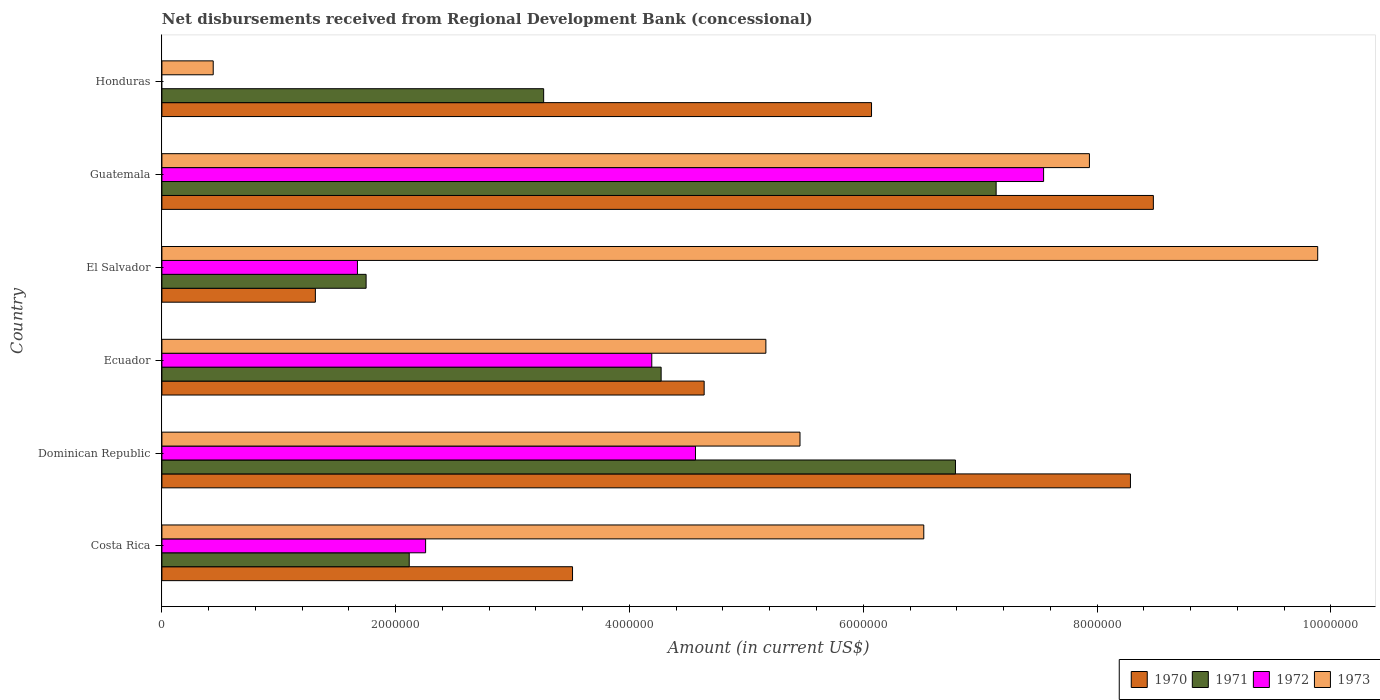How many different coloured bars are there?
Offer a terse response. 4. How many groups of bars are there?
Give a very brief answer. 6. What is the label of the 6th group of bars from the top?
Provide a short and direct response. Costa Rica. What is the amount of disbursements received from Regional Development Bank in 1972 in Honduras?
Make the answer very short. 0. Across all countries, what is the maximum amount of disbursements received from Regional Development Bank in 1970?
Make the answer very short. 8.48e+06. Across all countries, what is the minimum amount of disbursements received from Regional Development Bank in 1971?
Your response must be concise. 1.75e+06. In which country was the amount of disbursements received from Regional Development Bank in 1971 maximum?
Provide a short and direct response. Guatemala. What is the total amount of disbursements received from Regional Development Bank in 1973 in the graph?
Your answer should be compact. 3.54e+07. What is the difference between the amount of disbursements received from Regional Development Bank in 1973 in Dominican Republic and that in Ecuador?
Provide a short and direct response. 2.92e+05. What is the difference between the amount of disbursements received from Regional Development Bank in 1971 in Dominican Republic and the amount of disbursements received from Regional Development Bank in 1973 in Ecuador?
Provide a short and direct response. 1.62e+06. What is the average amount of disbursements received from Regional Development Bank in 1970 per country?
Offer a terse response. 5.38e+06. What is the difference between the amount of disbursements received from Regional Development Bank in 1972 and amount of disbursements received from Regional Development Bank in 1970 in Costa Rica?
Ensure brevity in your answer.  -1.26e+06. In how many countries, is the amount of disbursements received from Regional Development Bank in 1970 greater than 6000000 US$?
Offer a terse response. 3. What is the ratio of the amount of disbursements received from Regional Development Bank in 1971 in El Salvador to that in Guatemala?
Make the answer very short. 0.24. What is the difference between the highest and the second highest amount of disbursements received from Regional Development Bank in 1972?
Provide a short and direct response. 2.98e+06. What is the difference between the highest and the lowest amount of disbursements received from Regional Development Bank in 1973?
Your answer should be very brief. 9.45e+06. In how many countries, is the amount of disbursements received from Regional Development Bank in 1973 greater than the average amount of disbursements received from Regional Development Bank in 1973 taken over all countries?
Your response must be concise. 3. Are all the bars in the graph horizontal?
Your response must be concise. Yes. What is the difference between two consecutive major ticks on the X-axis?
Offer a terse response. 2.00e+06. Does the graph contain any zero values?
Your response must be concise. Yes. Does the graph contain grids?
Give a very brief answer. No. How are the legend labels stacked?
Provide a short and direct response. Horizontal. What is the title of the graph?
Your answer should be compact. Net disbursements received from Regional Development Bank (concessional). Does "1976" appear as one of the legend labels in the graph?
Your response must be concise. No. What is the Amount (in current US$) in 1970 in Costa Rica?
Provide a short and direct response. 3.51e+06. What is the Amount (in current US$) in 1971 in Costa Rica?
Your answer should be very brief. 2.12e+06. What is the Amount (in current US$) of 1972 in Costa Rica?
Your answer should be compact. 2.26e+06. What is the Amount (in current US$) in 1973 in Costa Rica?
Provide a succinct answer. 6.52e+06. What is the Amount (in current US$) of 1970 in Dominican Republic?
Provide a short and direct response. 8.29e+06. What is the Amount (in current US$) of 1971 in Dominican Republic?
Give a very brief answer. 6.79e+06. What is the Amount (in current US$) of 1972 in Dominican Republic?
Your answer should be compact. 4.56e+06. What is the Amount (in current US$) in 1973 in Dominican Republic?
Provide a short and direct response. 5.46e+06. What is the Amount (in current US$) of 1970 in Ecuador?
Your response must be concise. 4.64e+06. What is the Amount (in current US$) in 1971 in Ecuador?
Your answer should be very brief. 4.27e+06. What is the Amount (in current US$) of 1972 in Ecuador?
Your answer should be very brief. 4.19e+06. What is the Amount (in current US$) of 1973 in Ecuador?
Keep it short and to the point. 5.17e+06. What is the Amount (in current US$) in 1970 in El Salvador?
Provide a succinct answer. 1.31e+06. What is the Amount (in current US$) of 1971 in El Salvador?
Make the answer very short. 1.75e+06. What is the Amount (in current US$) in 1972 in El Salvador?
Provide a short and direct response. 1.67e+06. What is the Amount (in current US$) in 1973 in El Salvador?
Your response must be concise. 9.89e+06. What is the Amount (in current US$) of 1970 in Guatemala?
Give a very brief answer. 8.48e+06. What is the Amount (in current US$) of 1971 in Guatemala?
Your response must be concise. 7.14e+06. What is the Amount (in current US$) in 1972 in Guatemala?
Keep it short and to the point. 7.54e+06. What is the Amount (in current US$) of 1973 in Guatemala?
Your response must be concise. 7.94e+06. What is the Amount (in current US$) of 1970 in Honduras?
Give a very brief answer. 6.07e+06. What is the Amount (in current US$) in 1971 in Honduras?
Make the answer very short. 3.27e+06. What is the Amount (in current US$) of 1972 in Honduras?
Give a very brief answer. 0. What is the Amount (in current US$) in 1973 in Honduras?
Your response must be concise. 4.39e+05. Across all countries, what is the maximum Amount (in current US$) of 1970?
Your answer should be very brief. 8.48e+06. Across all countries, what is the maximum Amount (in current US$) in 1971?
Keep it short and to the point. 7.14e+06. Across all countries, what is the maximum Amount (in current US$) of 1972?
Ensure brevity in your answer.  7.54e+06. Across all countries, what is the maximum Amount (in current US$) in 1973?
Make the answer very short. 9.89e+06. Across all countries, what is the minimum Amount (in current US$) of 1970?
Make the answer very short. 1.31e+06. Across all countries, what is the minimum Amount (in current US$) in 1971?
Provide a succinct answer. 1.75e+06. Across all countries, what is the minimum Amount (in current US$) of 1972?
Offer a very short reply. 0. Across all countries, what is the minimum Amount (in current US$) of 1973?
Ensure brevity in your answer.  4.39e+05. What is the total Amount (in current US$) of 1970 in the graph?
Provide a succinct answer. 3.23e+07. What is the total Amount (in current US$) in 1971 in the graph?
Your response must be concise. 2.53e+07. What is the total Amount (in current US$) in 1972 in the graph?
Your answer should be compact. 2.02e+07. What is the total Amount (in current US$) of 1973 in the graph?
Provide a short and direct response. 3.54e+07. What is the difference between the Amount (in current US$) in 1970 in Costa Rica and that in Dominican Republic?
Offer a very short reply. -4.77e+06. What is the difference between the Amount (in current US$) in 1971 in Costa Rica and that in Dominican Republic?
Make the answer very short. -4.67e+06. What is the difference between the Amount (in current US$) of 1972 in Costa Rica and that in Dominican Republic?
Offer a terse response. -2.31e+06. What is the difference between the Amount (in current US$) of 1973 in Costa Rica and that in Dominican Republic?
Offer a very short reply. 1.06e+06. What is the difference between the Amount (in current US$) in 1970 in Costa Rica and that in Ecuador?
Give a very brief answer. -1.13e+06. What is the difference between the Amount (in current US$) in 1971 in Costa Rica and that in Ecuador?
Offer a terse response. -2.16e+06. What is the difference between the Amount (in current US$) in 1972 in Costa Rica and that in Ecuador?
Your response must be concise. -1.94e+06. What is the difference between the Amount (in current US$) in 1973 in Costa Rica and that in Ecuador?
Provide a short and direct response. 1.35e+06. What is the difference between the Amount (in current US$) in 1970 in Costa Rica and that in El Salvador?
Make the answer very short. 2.20e+06. What is the difference between the Amount (in current US$) of 1971 in Costa Rica and that in El Salvador?
Make the answer very short. 3.69e+05. What is the difference between the Amount (in current US$) of 1972 in Costa Rica and that in El Salvador?
Provide a short and direct response. 5.83e+05. What is the difference between the Amount (in current US$) of 1973 in Costa Rica and that in El Salvador?
Your answer should be very brief. -3.37e+06. What is the difference between the Amount (in current US$) in 1970 in Costa Rica and that in Guatemala?
Give a very brief answer. -4.97e+06. What is the difference between the Amount (in current US$) of 1971 in Costa Rica and that in Guatemala?
Make the answer very short. -5.02e+06. What is the difference between the Amount (in current US$) of 1972 in Costa Rica and that in Guatemala?
Your answer should be very brief. -5.29e+06. What is the difference between the Amount (in current US$) in 1973 in Costa Rica and that in Guatemala?
Your answer should be compact. -1.42e+06. What is the difference between the Amount (in current US$) in 1970 in Costa Rica and that in Honduras?
Make the answer very short. -2.56e+06. What is the difference between the Amount (in current US$) of 1971 in Costa Rica and that in Honduras?
Offer a terse response. -1.15e+06. What is the difference between the Amount (in current US$) of 1973 in Costa Rica and that in Honduras?
Provide a short and direct response. 6.08e+06. What is the difference between the Amount (in current US$) of 1970 in Dominican Republic and that in Ecuador?
Provide a succinct answer. 3.65e+06. What is the difference between the Amount (in current US$) in 1971 in Dominican Republic and that in Ecuador?
Give a very brief answer. 2.52e+06. What is the difference between the Amount (in current US$) in 1972 in Dominican Republic and that in Ecuador?
Give a very brief answer. 3.74e+05. What is the difference between the Amount (in current US$) of 1973 in Dominican Republic and that in Ecuador?
Your response must be concise. 2.92e+05. What is the difference between the Amount (in current US$) in 1970 in Dominican Republic and that in El Salvador?
Provide a short and direct response. 6.97e+06. What is the difference between the Amount (in current US$) in 1971 in Dominican Republic and that in El Salvador?
Make the answer very short. 5.04e+06. What is the difference between the Amount (in current US$) of 1972 in Dominican Republic and that in El Salvador?
Your answer should be compact. 2.89e+06. What is the difference between the Amount (in current US$) in 1973 in Dominican Republic and that in El Salvador?
Keep it short and to the point. -4.43e+06. What is the difference between the Amount (in current US$) of 1970 in Dominican Republic and that in Guatemala?
Provide a succinct answer. -1.96e+05. What is the difference between the Amount (in current US$) in 1971 in Dominican Republic and that in Guatemala?
Provide a succinct answer. -3.48e+05. What is the difference between the Amount (in current US$) in 1972 in Dominican Republic and that in Guatemala?
Offer a terse response. -2.98e+06. What is the difference between the Amount (in current US$) of 1973 in Dominican Republic and that in Guatemala?
Provide a succinct answer. -2.48e+06. What is the difference between the Amount (in current US$) of 1970 in Dominican Republic and that in Honduras?
Offer a terse response. 2.22e+06. What is the difference between the Amount (in current US$) of 1971 in Dominican Republic and that in Honduras?
Give a very brief answer. 3.52e+06. What is the difference between the Amount (in current US$) in 1973 in Dominican Republic and that in Honduras?
Your response must be concise. 5.02e+06. What is the difference between the Amount (in current US$) of 1970 in Ecuador and that in El Salvador?
Keep it short and to the point. 3.33e+06. What is the difference between the Amount (in current US$) of 1971 in Ecuador and that in El Salvador?
Your answer should be compact. 2.52e+06. What is the difference between the Amount (in current US$) in 1972 in Ecuador and that in El Salvador?
Offer a very short reply. 2.52e+06. What is the difference between the Amount (in current US$) in 1973 in Ecuador and that in El Salvador?
Ensure brevity in your answer.  -4.72e+06. What is the difference between the Amount (in current US$) of 1970 in Ecuador and that in Guatemala?
Provide a short and direct response. -3.84e+06. What is the difference between the Amount (in current US$) in 1971 in Ecuador and that in Guatemala?
Provide a succinct answer. -2.87e+06. What is the difference between the Amount (in current US$) in 1972 in Ecuador and that in Guatemala?
Make the answer very short. -3.35e+06. What is the difference between the Amount (in current US$) of 1973 in Ecuador and that in Guatemala?
Provide a short and direct response. -2.77e+06. What is the difference between the Amount (in current US$) in 1970 in Ecuador and that in Honduras?
Provide a short and direct response. -1.43e+06. What is the difference between the Amount (in current US$) in 1971 in Ecuador and that in Honduras?
Your answer should be very brief. 1.00e+06. What is the difference between the Amount (in current US$) in 1973 in Ecuador and that in Honduras?
Offer a very short reply. 4.73e+06. What is the difference between the Amount (in current US$) of 1970 in El Salvador and that in Guatemala?
Give a very brief answer. -7.17e+06. What is the difference between the Amount (in current US$) of 1971 in El Salvador and that in Guatemala?
Make the answer very short. -5.39e+06. What is the difference between the Amount (in current US$) of 1972 in El Salvador and that in Guatemala?
Your answer should be compact. -5.87e+06. What is the difference between the Amount (in current US$) in 1973 in El Salvador and that in Guatemala?
Offer a very short reply. 1.95e+06. What is the difference between the Amount (in current US$) in 1970 in El Salvador and that in Honduras?
Provide a succinct answer. -4.76e+06. What is the difference between the Amount (in current US$) of 1971 in El Salvador and that in Honduras?
Keep it short and to the point. -1.52e+06. What is the difference between the Amount (in current US$) of 1973 in El Salvador and that in Honduras?
Make the answer very short. 9.45e+06. What is the difference between the Amount (in current US$) of 1970 in Guatemala and that in Honduras?
Your response must be concise. 2.41e+06. What is the difference between the Amount (in current US$) of 1971 in Guatemala and that in Honduras?
Make the answer very short. 3.87e+06. What is the difference between the Amount (in current US$) of 1973 in Guatemala and that in Honduras?
Offer a terse response. 7.50e+06. What is the difference between the Amount (in current US$) in 1970 in Costa Rica and the Amount (in current US$) in 1971 in Dominican Republic?
Ensure brevity in your answer.  -3.28e+06. What is the difference between the Amount (in current US$) in 1970 in Costa Rica and the Amount (in current US$) in 1972 in Dominican Republic?
Make the answer very short. -1.05e+06. What is the difference between the Amount (in current US$) of 1970 in Costa Rica and the Amount (in current US$) of 1973 in Dominican Republic?
Your response must be concise. -1.95e+06. What is the difference between the Amount (in current US$) in 1971 in Costa Rica and the Amount (in current US$) in 1972 in Dominican Republic?
Provide a succinct answer. -2.45e+06. What is the difference between the Amount (in current US$) of 1971 in Costa Rica and the Amount (in current US$) of 1973 in Dominican Republic?
Make the answer very short. -3.34e+06. What is the difference between the Amount (in current US$) in 1972 in Costa Rica and the Amount (in current US$) in 1973 in Dominican Republic?
Keep it short and to the point. -3.20e+06. What is the difference between the Amount (in current US$) of 1970 in Costa Rica and the Amount (in current US$) of 1971 in Ecuador?
Your response must be concise. -7.58e+05. What is the difference between the Amount (in current US$) in 1970 in Costa Rica and the Amount (in current US$) in 1972 in Ecuador?
Your answer should be compact. -6.78e+05. What is the difference between the Amount (in current US$) in 1970 in Costa Rica and the Amount (in current US$) in 1973 in Ecuador?
Offer a terse response. -1.65e+06. What is the difference between the Amount (in current US$) of 1971 in Costa Rica and the Amount (in current US$) of 1972 in Ecuador?
Ensure brevity in your answer.  -2.08e+06. What is the difference between the Amount (in current US$) in 1971 in Costa Rica and the Amount (in current US$) in 1973 in Ecuador?
Your response must be concise. -3.05e+06. What is the difference between the Amount (in current US$) of 1972 in Costa Rica and the Amount (in current US$) of 1973 in Ecuador?
Give a very brief answer. -2.91e+06. What is the difference between the Amount (in current US$) of 1970 in Costa Rica and the Amount (in current US$) of 1971 in El Salvador?
Make the answer very short. 1.77e+06. What is the difference between the Amount (in current US$) in 1970 in Costa Rica and the Amount (in current US$) in 1972 in El Salvador?
Your answer should be very brief. 1.84e+06. What is the difference between the Amount (in current US$) of 1970 in Costa Rica and the Amount (in current US$) of 1973 in El Salvador?
Offer a terse response. -6.38e+06. What is the difference between the Amount (in current US$) of 1971 in Costa Rica and the Amount (in current US$) of 1972 in El Salvador?
Your answer should be very brief. 4.43e+05. What is the difference between the Amount (in current US$) in 1971 in Costa Rica and the Amount (in current US$) in 1973 in El Salvador?
Give a very brief answer. -7.77e+06. What is the difference between the Amount (in current US$) of 1972 in Costa Rica and the Amount (in current US$) of 1973 in El Salvador?
Provide a succinct answer. -7.63e+06. What is the difference between the Amount (in current US$) in 1970 in Costa Rica and the Amount (in current US$) in 1971 in Guatemala?
Give a very brief answer. -3.62e+06. What is the difference between the Amount (in current US$) in 1970 in Costa Rica and the Amount (in current US$) in 1972 in Guatemala?
Provide a succinct answer. -4.03e+06. What is the difference between the Amount (in current US$) in 1970 in Costa Rica and the Amount (in current US$) in 1973 in Guatemala?
Keep it short and to the point. -4.42e+06. What is the difference between the Amount (in current US$) in 1971 in Costa Rica and the Amount (in current US$) in 1972 in Guatemala?
Your response must be concise. -5.43e+06. What is the difference between the Amount (in current US$) in 1971 in Costa Rica and the Amount (in current US$) in 1973 in Guatemala?
Give a very brief answer. -5.82e+06. What is the difference between the Amount (in current US$) in 1972 in Costa Rica and the Amount (in current US$) in 1973 in Guatemala?
Offer a very short reply. -5.68e+06. What is the difference between the Amount (in current US$) in 1970 in Costa Rica and the Amount (in current US$) in 1971 in Honduras?
Provide a succinct answer. 2.47e+05. What is the difference between the Amount (in current US$) of 1970 in Costa Rica and the Amount (in current US$) of 1973 in Honduras?
Provide a short and direct response. 3.07e+06. What is the difference between the Amount (in current US$) in 1971 in Costa Rica and the Amount (in current US$) in 1973 in Honduras?
Your answer should be compact. 1.68e+06. What is the difference between the Amount (in current US$) in 1972 in Costa Rica and the Amount (in current US$) in 1973 in Honduras?
Make the answer very short. 1.82e+06. What is the difference between the Amount (in current US$) in 1970 in Dominican Republic and the Amount (in current US$) in 1971 in Ecuador?
Offer a very short reply. 4.02e+06. What is the difference between the Amount (in current US$) in 1970 in Dominican Republic and the Amount (in current US$) in 1972 in Ecuador?
Ensure brevity in your answer.  4.10e+06. What is the difference between the Amount (in current US$) in 1970 in Dominican Republic and the Amount (in current US$) in 1973 in Ecuador?
Your answer should be compact. 3.12e+06. What is the difference between the Amount (in current US$) in 1971 in Dominican Republic and the Amount (in current US$) in 1972 in Ecuador?
Keep it short and to the point. 2.60e+06. What is the difference between the Amount (in current US$) of 1971 in Dominican Republic and the Amount (in current US$) of 1973 in Ecuador?
Your response must be concise. 1.62e+06. What is the difference between the Amount (in current US$) in 1972 in Dominican Republic and the Amount (in current US$) in 1973 in Ecuador?
Provide a short and direct response. -6.02e+05. What is the difference between the Amount (in current US$) of 1970 in Dominican Republic and the Amount (in current US$) of 1971 in El Salvador?
Make the answer very short. 6.54e+06. What is the difference between the Amount (in current US$) of 1970 in Dominican Republic and the Amount (in current US$) of 1972 in El Salvador?
Provide a short and direct response. 6.61e+06. What is the difference between the Amount (in current US$) of 1970 in Dominican Republic and the Amount (in current US$) of 1973 in El Salvador?
Your response must be concise. -1.60e+06. What is the difference between the Amount (in current US$) of 1971 in Dominican Republic and the Amount (in current US$) of 1972 in El Salvador?
Provide a short and direct response. 5.12e+06. What is the difference between the Amount (in current US$) of 1971 in Dominican Republic and the Amount (in current US$) of 1973 in El Salvador?
Give a very brief answer. -3.10e+06. What is the difference between the Amount (in current US$) of 1972 in Dominican Republic and the Amount (in current US$) of 1973 in El Salvador?
Provide a succinct answer. -5.32e+06. What is the difference between the Amount (in current US$) in 1970 in Dominican Republic and the Amount (in current US$) in 1971 in Guatemala?
Offer a terse response. 1.15e+06. What is the difference between the Amount (in current US$) in 1970 in Dominican Republic and the Amount (in current US$) in 1972 in Guatemala?
Keep it short and to the point. 7.43e+05. What is the difference between the Amount (in current US$) in 1970 in Dominican Republic and the Amount (in current US$) in 1973 in Guatemala?
Keep it short and to the point. 3.51e+05. What is the difference between the Amount (in current US$) of 1971 in Dominican Republic and the Amount (in current US$) of 1972 in Guatemala?
Provide a short and direct response. -7.54e+05. What is the difference between the Amount (in current US$) of 1971 in Dominican Republic and the Amount (in current US$) of 1973 in Guatemala?
Give a very brief answer. -1.15e+06. What is the difference between the Amount (in current US$) of 1972 in Dominican Republic and the Amount (in current US$) of 1973 in Guatemala?
Offer a very short reply. -3.37e+06. What is the difference between the Amount (in current US$) in 1970 in Dominican Republic and the Amount (in current US$) in 1971 in Honduras?
Your answer should be very brief. 5.02e+06. What is the difference between the Amount (in current US$) in 1970 in Dominican Republic and the Amount (in current US$) in 1973 in Honduras?
Give a very brief answer. 7.85e+06. What is the difference between the Amount (in current US$) in 1971 in Dominican Republic and the Amount (in current US$) in 1973 in Honduras?
Offer a terse response. 6.35e+06. What is the difference between the Amount (in current US$) in 1972 in Dominican Republic and the Amount (in current US$) in 1973 in Honduras?
Give a very brief answer. 4.13e+06. What is the difference between the Amount (in current US$) in 1970 in Ecuador and the Amount (in current US$) in 1971 in El Salvador?
Your answer should be compact. 2.89e+06. What is the difference between the Amount (in current US$) of 1970 in Ecuador and the Amount (in current US$) of 1972 in El Salvador?
Make the answer very short. 2.97e+06. What is the difference between the Amount (in current US$) of 1970 in Ecuador and the Amount (in current US$) of 1973 in El Salvador?
Offer a terse response. -5.25e+06. What is the difference between the Amount (in current US$) in 1971 in Ecuador and the Amount (in current US$) in 1972 in El Salvador?
Offer a terse response. 2.60e+06. What is the difference between the Amount (in current US$) in 1971 in Ecuador and the Amount (in current US$) in 1973 in El Salvador?
Provide a short and direct response. -5.62e+06. What is the difference between the Amount (in current US$) in 1972 in Ecuador and the Amount (in current US$) in 1973 in El Salvador?
Make the answer very short. -5.70e+06. What is the difference between the Amount (in current US$) of 1970 in Ecuador and the Amount (in current US$) of 1971 in Guatemala?
Provide a short and direct response. -2.50e+06. What is the difference between the Amount (in current US$) of 1970 in Ecuador and the Amount (in current US$) of 1972 in Guatemala?
Your response must be concise. -2.90e+06. What is the difference between the Amount (in current US$) of 1970 in Ecuador and the Amount (in current US$) of 1973 in Guatemala?
Offer a terse response. -3.30e+06. What is the difference between the Amount (in current US$) of 1971 in Ecuador and the Amount (in current US$) of 1972 in Guatemala?
Ensure brevity in your answer.  -3.27e+06. What is the difference between the Amount (in current US$) in 1971 in Ecuador and the Amount (in current US$) in 1973 in Guatemala?
Offer a terse response. -3.66e+06. What is the difference between the Amount (in current US$) of 1972 in Ecuador and the Amount (in current US$) of 1973 in Guatemala?
Provide a short and direct response. -3.74e+06. What is the difference between the Amount (in current US$) in 1970 in Ecuador and the Amount (in current US$) in 1971 in Honduras?
Your answer should be compact. 1.37e+06. What is the difference between the Amount (in current US$) in 1970 in Ecuador and the Amount (in current US$) in 1973 in Honduras?
Ensure brevity in your answer.  4.20e+06. What is the difference between the Amount (in current US$) in 1971 in Ecuador and the Amount (in current US$) in 1973 in Honduras?
Offer a very short reply. 3.83e+06. What is the difference between the Amount (in current US$) in 1972 in Ecuador and the Amount (in current US$) in 1973 in Honduras?
Make the answer very short. 3.75e+06. What is the difference between the Amount (in current US$) in 1970 in El Salvador and the Amount (in current US$) in 1971 in Guatemala?
Offer a terse response. -5.82e+06. What is the difference between the Amount (in current US$) in 1970 in El Salvador and the Amount (in current US$) in 1972 in Guatemala?
Keep it short and to the point. -6.23e+06. What is the difference between the Amount (in current US$) of 1970 in El Salvador and the Amount (in current US$) of 1973 in Guatemala?
Keep it short and to the point. -6.62e+06. What is the difference between the Amount (in current US$) in 1971 in El Salvador and the Amount (in current US$) in 1972 in Guatemala?
Provide a short and direct response. -5.80e+06. What is the difference between the Amount (in current US$) of 1971 in El Salvador and the Amount (in current US$) of 1973 in Guatemala?
Ensure brevity in your answer.  -6.19e+06. What is the difference between the Amount (in current US$) in 1972 in El Salvador and the Amount (in current US$) in 1973 in Guatemala?
Give a very brief answer. -6.26e+06. What is the difference between the Amount (in current US$) in 1970 in El Salvador and the Amount (in current US$) in 1971 in Honduras?
Ensure brevity in your answer.  -1.95e+06. What is the difference between the Amount (in current US$) of 1970 in El Salvador and the Amount (in current US$) of 1973 in Honduras?
Ensure brevity in your answer.  8.74e+05. What is the difference between the Amount (in current US$) of 1971 in El Salvador and the Amount (in current US$) of 1973 in Honduras?
Ensure brevity in your answer.  1.31e+06. What is the difference between the Amount (in current US$) of 1972 in El Salvador and the Amount (in current US$) of 1973 in Honduras?
Provide a short and direct response. 1.23e+06. What is the difference between the Amount (in current US$) of 1970 in Guatemala and the Amount (in current US$) of 1971 in Honduras?
Your answer should be very brief. 5.22e+06. What is the difference between the Amount (in current US$) in 1970 in Guatemala and the Amount (in current US$) in 1973 in Honduras?
Make the answer very short. 8.04e+06. What is the difference between the Amount (in current US$) of 1971 in Guatemala and the Amount (in current US$) of 1973 in Honduras?
Offer a terse response. 6.70e+06. What is the difference between the Amount (in current US$) of 1972 in Guatemala and the Amount (in current US$) of 1973 in Honduras?
Your answer should be very brief. 7.10e+06. What is the average Amount (in current US$) in 1970 per country?
Your answer should be compact. 5.38e+06. What is the average Amount (in current US$) of 1971 per country?
Offer a very short reply. 4.22e+06. What is the average Amount (in current US$) in 1972 per country?
Your response must be concise. 3.37e+06. What is the average Amount (in current US$) in 1973 per country?
Your response must be concise. 5.90e+06. What is the difference between the Amount (in current US$) of 1970 and Amount (in current US$) of 1971 in Costa Rica?
Your response must be concise. 1.40e+06. What is the difference between the Amount (in current US$) in 1970 and Amount (in current US$) in 1972 in Costa Rica?
Give a very brief answer. 1.26e+06. What is the difference between the Amount (in current US$) of 1970 and Amount (in current US$) of 1973 in Costa Rica?
Provide a succinct answer. -3.00e+06. What is the difference between the Amount (in current US$) in 1971 and Amount (in current US$) in 1972 in Costa Rica?
Give a very brief answer. -1.40e+05. What is the difference between the Amount (in current US$) in 1971 and Amount (in current US$) in 1973 in Costa Rica?
Your answer should be very brief. -4.40e+06. What is the difference between the Amount (in current US$) of 1972 and Amount (in current US$) of 1973 in Costa Rica?
Ensure brevity in your answer.  -4.26e+06. What is the difference between the Amount (in current US$) of 1970 and Amount (in current US$) of 1971 in Dominican Republic?
Make the answer very short. 1.50e+06. What is the difference between the Amount (in current US$) of 1970 and Amount (in current US$) of 1972 in Dominican Republic?
Offer a very short reply. 3.72e+06. What is the difference between the Amount (in current US$) of 1970 and Amount (in current US$) of 1973 in Dominican Republic?
Give a very brief answer. 2.83e+06. What is the difference between the Amount (in current US$) of 1971 and Amount (in current US$) of 1972 in Dominican Republic?
Make the answer very short. 2.22e+06. What is the difference between the Amount (in current US$) in 1971 and Amount (in current US$) in 1973 in Dominican Republic?
Your response must be concise. 1.33e+06. What is the difference between the Amount (in current US$) of 1972 and Amount (in current US$) of 1973 in Dominican Republic?
Make the answer very short. -8.94e+05. What is the difference between the Amount (in current US$) in 1970 and Amount (in current US$) in 1971 in Ecuador?
Your response must be concise. 3.68e+05. What is the difference between the Amount (in current US$) in 1970 and Amount (in current US$) in 1972 in Ecuador?
Make the answer very short. 4.48e+05. What is the difference between the Amount (in current US$) in 1970 and Amount (in current US$) in 1973 in Ecuador?
Offer a very short reply. -5.28e+05. What is the difference between the Amount (in current US$) in 1971 and Amount (in current US$) in 1973 in Ecuador?
Your answer should be compact. -8.96e+05. What is the difference between the Amount (in current US$) of 1972 and Amount (in current US$) of 1973 in Ecuador?
Make the answer very short. -9.76e+05. What is the difference between the Amount (in current US$) in 1970 and Amount (in current US$) in 1971 in El Salvador?
Ensure brevity in your answer.  -4.34e+05. What is the difference between the Amount (in current US$) in 1970 and Amount (in current US$) in 1972 in El Salvador?
Provide a succinct answer. -3.60e+05. What is the difference between the Amount (in current US$) of 1970 and Amount (in current US$) of 1973 in El Salvador?
Offer a terse response. -8.58e+06. What is the difference between the Amount (in current US$) in 1971 and Amount (in current US$) in 1972 in El Salvador?
Provide a short and direct response. 7.40e+04. What is the difference between the Amount (in current US$) of 1971 and Amount (in current US$) of 1973 in El Salvador?
Keep it short and to the point. -8.14e+06. What is the difference between the Amount (in current US$) of 1972 and Amount (in current US$) of 1973 in El Salvador?
Provide a short and direct response. -8.22e+06. What is the difference between the Amount (in current US$) of 1970 and Amount (in current US$) of 1971 in Guatemala?
Your response must be concise. 1.34e+06. What is the difference between the Amount (in current US$) of 1970 and Amount (in current US$) of 1972 in Guatemala?
Provide a succinct answer. 9.39e+05. What is the difference between the Amount (in current US$) of 1970 and Amount (in current US$) of 1973 in Guatemala?
Provide a short and direct response. 5.47e+05. What is the difference between the Amount (in current US$) of 1971 and Amount (in current US$) of 1972 in Guatemala?
Make the answer very short. -4.06e+05. What is the difference between the Amount (in current US$) in 1971 and Amount (in current US$) in 1973 in Guatemala?
Offer a terse response. -7.98e+05. What is the difference between the Amount (in current US$) in 1972 and Amount (in current US$) in 1973 in Guatemala?
Keep it short and to the point. -3.92e+05. What is the difference between the Amount (in current US$) in 1970 and Amount (in current US$) in 1971 in Honduras?
Ensure brevity in your answer.  2.80e+06. What is the difference between the Amount (in current US$) of 1970 and Amount (in current US$) of 1973 in Honduras?
Provide a short and direct response. 5.63e+06. What is the difference between the Amount (in current US$) in 1971 and Amount (in current US$) in 1973 in Honduras?
Provide a short and direct response. 2.83e+06. What is the ratio of the Amount (in current US$) in 1970 in Costa Rica to that in Dominican Republic?
Your response must be concise. 0.42. What is the ratio of the Amount (in current US$) in 1971 in Costa Rica to that in Dominican Republic?
Your response must be concise. 0.31. What is the ratio of the Amount (in current US$) in 1972 in Costa Rica to that in Dominican Republic?
Provide a short and direct response. 0.49. What is the ratio of the Amount (in current US$) in 1973 in Costa Rica to that in Dominican Republic?
Your answer should be very brief. 1.19. What is the ratio of the Amount (in current US$) of 1970 in Costa Rica to that in Ecuador?
Your response must be concise. 0.76. What is the ratio of the Amount (in current US$) in 1971 in Costa Rica to that in Ecuador?
Make the answer very short. 0.5. What is the ratio of the Amount (in current US$) in 1972 in Costa Rica to that in Ecuador?
Give a very brief answer. 0.54. What is the ratio of the Amount (in current US$) in 1973 in Costa Rica to that in Ecuador?
Provide a succinct answer. 1.26. What is the ratio of the Amount (in current US$) of 1970 in Costa Rica to that in El Salvador?
Ensure brevity in your answer.  2.68. What is the ratio of the Amount (in current US$) in 1971 in Costa Rica to that in El Salvador?
Offer a very short reply. 1.21. What is the ratio of the Amount (in current US$) of 1972 in Costa Rica to that in El Salvador?
Your answer should be very brief. 1.35. What is the ratio of the Amount (in current US$) in 1973 in Costa Rica to that in El Salvador?
Keep it short and to the point. 0.66. What is the ratio of the Amount (in current US$) of 1970 in Costa Rica to that in Guatemala?
Offer a very short reply. 0.41. What is the ratio of the Amount (in current US$) in 1971 in Costa Rica to that in Guatemala?
Offer a very short reply. 0.3. What is the ratio of the Amount (in current US$) in 1972 in Costa Rica to that in Guatemala?
Your answer should be compact. 0.3. What is the ratio of the Amount (in current US$) in 1973 in Costa Rica to that in Guatemala?
Offer a very short reply. 0.82. What is the ratio of the Amount (in current US$) in 1970 in Costa Rica to that in Honduras?
Your answer should be very brief. 0.58. What is the ratio of the Amount (in current US$) of 1971 in Costa Rica to that in Honduras?
Offer a very short reply. 0.65. What is the ratio of the Amount (in current US$) of 1973 in Costa Rica to that in Honduras?
Offer a very short reply. 14.85. What is the ratio of the Amount (in current US$) of 1970 in Dominican Republic to that in Ecuador?
Offer a very short reply. 1.79. What is the ratio of the Amount (in current US$) in 1971 in Dominican Republic to that in Ecuador?
Your response must be concise. 1.59. What is the ratio of the Amount (in current US$) of 1972 in Dominican Republic to that in Ecuador?
Make the answer very short. 1.09. What is the ratio of the Amount (in current US$) of 1973 in Dominican Republic to that in Ecuador?
Provide a succinct answer. 1.06. What is the ratio of the Amount (in current US$) in 1970 in Dominican Republic to that in El Salvador?
Offer a terse response. 6.31. What is the ratio of the Amount (in current US$) of 1971 in Dominican Republic to that in El Salvador?
Your response must be concise. 3.89. What is the ratio of the Amount (in current US$) in 1972 in Dominican Republic to that in El Salvador?
Offer a terse response. 2.73. What is the ratio of the Amount (in current US$) of 1973 in Dominican Republic to that in El Salvador?
Make the answer very short. 0.55. What is the ratio of the Amount (in current US$) of 1970 in Dominican Republic to that in Guatemala?
Ensure brevity in your answer.  0.98. What is the ratio of the Amount (in current US$) of 1971 in Dominican Republic to that in Guatemala?
Offer a terse response. 0.95. What is the ratio of the Amount (in current US$) in 1972 in Dominican Republic to that in Guatemala?
Your answer should be compact. 0.61. What is the ratio of the Amount (in current US$) of 1973 in Dominican Republic to that in Guatemala?
Ensure brevity in your answer.  0.69. What is the ratio of the Amount (in current US$) of 1970 in Dominican Republic to that in Honduras?
Your answer should be very brief. 1.36. What is the ratio of the Amount (in current US$) in 1971 in Dominican Republic to that in Honduras?
Give a very brief answer. 2.08. What is the ratio of the Amount (in current US$) in 1973 in Dominican Republic to that in Honduras?
Give a very brief answer. 12.44. What is the ratio of the Amount (in current US$) in 1970 in Ecuador to that in El Salvador?
Your response must be concise. 3.53. What is the ratio of the Amount (in current US$) of 1971 in Ecuador to that in El Salvador?
Offer a very short reply. 2.44. What is the ratio of the Amount (in current US$) in 1972 in Ecuador to that in El Salvador?
Offer a terse response. 2.51. What is the ratio of the Amount (in current US$) in 1973 in Ecuador to that in El Salvador?
Provide a short and direct response. 0.52. What is the ratio of the Amount (in current US$) of 1970 in Ecuador to that in Guatemala?
Your answer should be very brief. 0.55. What is the ratio of the Amount (in current US$) in 1971 in Ecuador to that in Guatemala?
Your response must be concise. 0.6. What is the ratio of the Amount (in current US$) of 1972 in Ecuador to that in Guatemala?
Your answer should be very brief. 0.56. What is the ratio of the Amount (in current US$) in 1973 in Ecuador to that in Guatemala?
Ensure brevity in your answer.  0.65. What is the ratio of the Amount (in current US$) of 1970 in Ecuador to that in Honduras?
Ensure brevity in your answer.  0.76. What is the ratio of the Amount (in current US$) of 1971 in Ecuador to that in Honduras?
Your answer should be compact. 1.31. What is the ratio of the Amount (in current US$) of 1973 in Ecuador to that in Honduras?
Offer a terse response. 11.77. What is the ratio of the Amount (in current US$) of 1970 in El Salvador to that in Guatemala?
Give a very brief answer. 0.15. What is the ratio of the Amount (in current US$) of 1971 in El Salvador to that in Guatemala?
Keep it short and to the point. 0.24. What is the ratio of the Amount (in current US$) of 1972 in El Salvador to that in Guatemala?
Your answer should be very brief. 0.22. What is the ratio of the Amount (in current US$) in 1973 in El Salvador to that in Guatemala?
Your answer should be compact. 1.25. What is the ratio of the Amount (in current US$) of 1970 in El Salvador to that in Honduras?
Your answer should be very brief. 0.22. What is the ratio of the Amount (in current US$) of 1971 in El Salvador to that in Honduras?
Provide a short and direct response. 0.53. What is the ratio of the Amount (in current US$) of 1973 in El Salvador to that in Honduras?
Keep it short and to the point. 22.52. What is the ratio of the Amount (in current US$) of 1970 in Guatemala to that in Honduras?
Give a very brief answer. 1.4. What is the ratio of the Amount (in current US$) of 1971 in Guatemala to that in Honduras?
Offer a terse response. 2.19. What is the ratio of the Amount (in current US$) of 1973 in Guatemala to that in Honduras?
Your response must be concise. 18.08. What is the difference between the highest and the second highest Amount (in current US$) of 1970?
Your answer should be compact. 1.96e+05. What is the difference between the highest and the second highest Amount (in current US$) of 1971?
Give a very brief answer. 3.48e+05. What is the difference between the highest and the second highest Amount (in current US$) in 1972?
Your answer should be compact. 2.98e+06. What is the difference between the highest and the second highest Amount (in current US$) of 1973?
Keep it short and to the point. 1.95e+06. What is the difference between the highest and the lowest Amount (in current US$) of 1970?
Offer a terse response. 7.17e+06. What is the difference between the highest and the lowest Amount (in current US$) in 1971?
Provide a short and direct response. 5.39e+06. What is the difference between the highest and the lowest Amount (in current US$) of 1972?
Offer a very short reply. 7.54e+06. What is the difference between the highest and the lowest Amount (in current US$) in 1973?
Your response must be concise. 9.45e+06. 